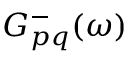Convert formula to latex. <formula><loc_0><loc_0><loc_500><loc_500>G _ { p q } ^ { - } ( \omega )</formula> 